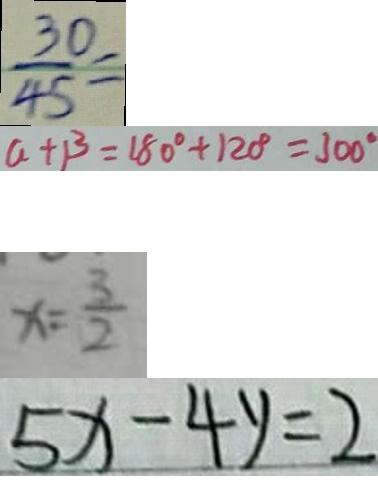<formula> <loc_0><loc_0><loc_500><loc_500>\frac { 3 0 } { 4 5 } = 
 a + \beta = 1 8 0 ^ { \circ } + 1 2 0 ^ { \circ } = 3 0 0 ^ { \circ } 
 x = \frac { 3 } { 2 } 
 5 x - 4 y = 2</formula> 